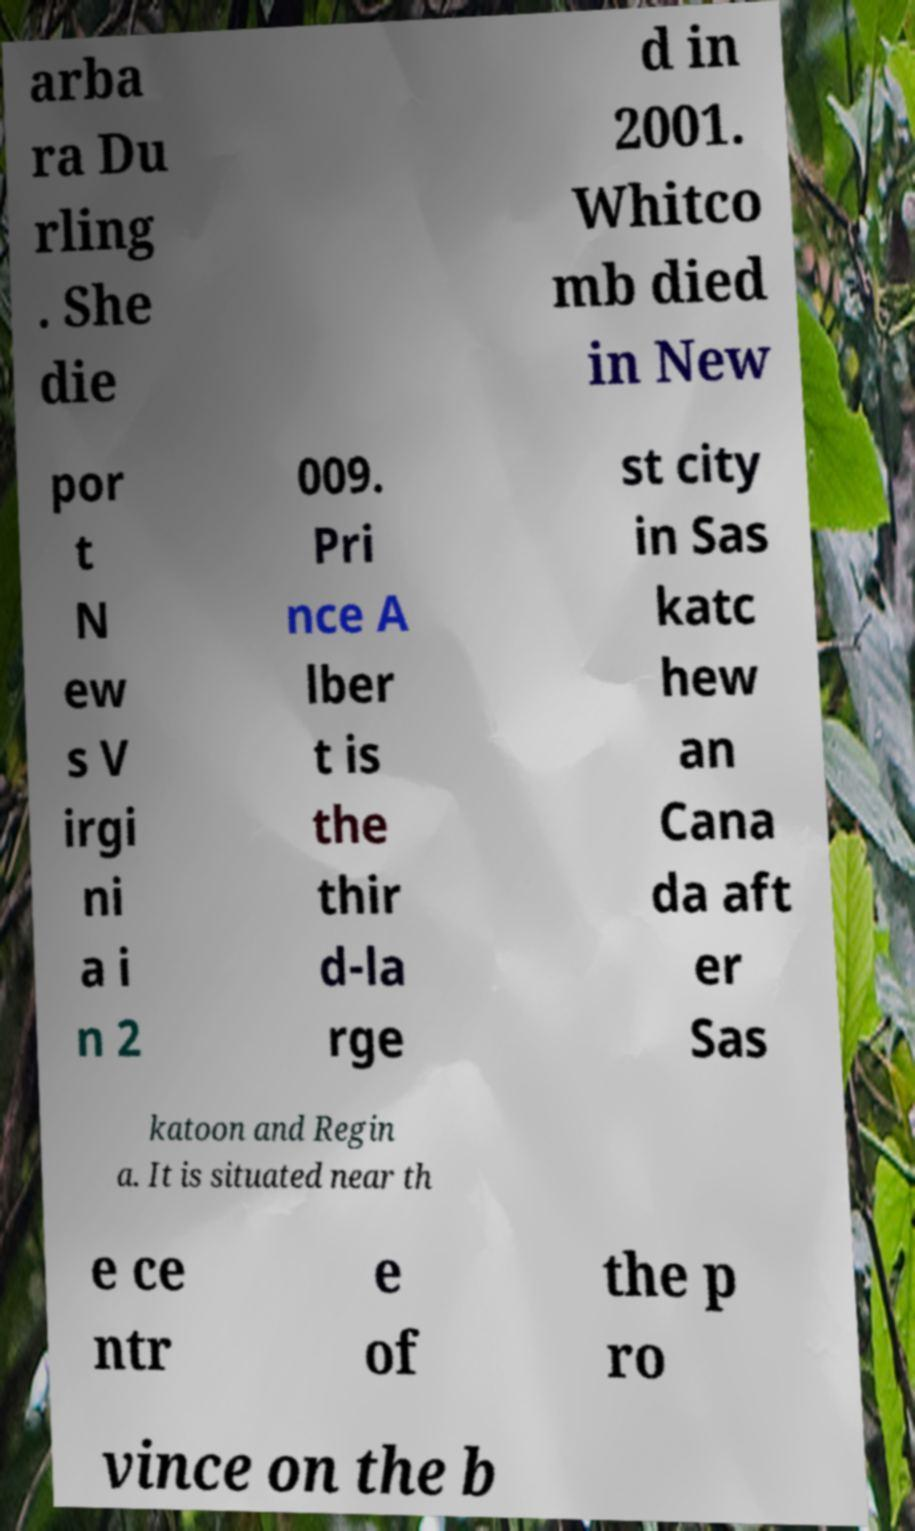Could you extract and type out the text from this image? arba ra Du rling . She die d in 2001. Whitco mb died in New por t N ew s V irgi ni a i n 2 009. Pri nce A lber t is the thir d-la rge st city in Sas katc hew an Cana da aft er Sas katoon and Regin a. It is situated near th e ce ntr e of the p ro vince on the b 